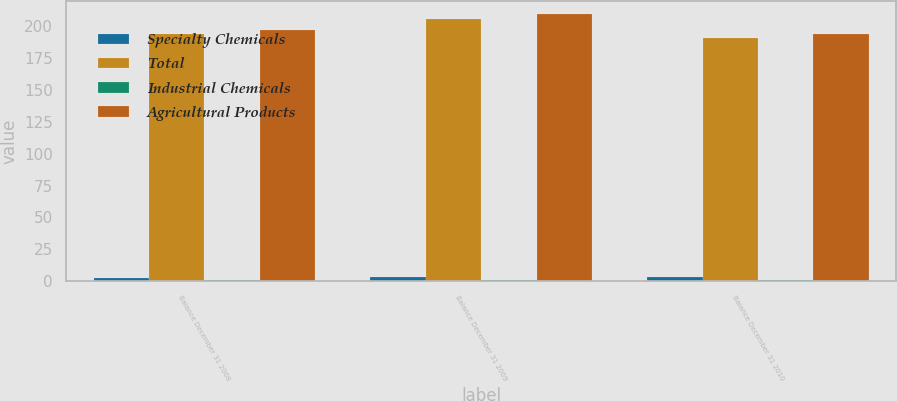<chart> <loc_0><loc_0><loc_500><loc_500><stacked_bar_chart><ecel><fcel>Balance December 31 2008<fcel>Balance December 31 2009<fcel>Balance December 31 2010<nl><fcel>Specialty Chemicals<fcel>2.7<fcel>2.8<fcel>2.8<nl><fcel>Total<fcel>193.7<fcel>206.1<fcel>191<nl><fcel>Industrial Chemicals<fcel>0.6<fcel>0.6<fcel>0.6<nl><fcel>Agricultural Products<fcel>197<fcel>209.5<fcel>194.4<nl></chart> 